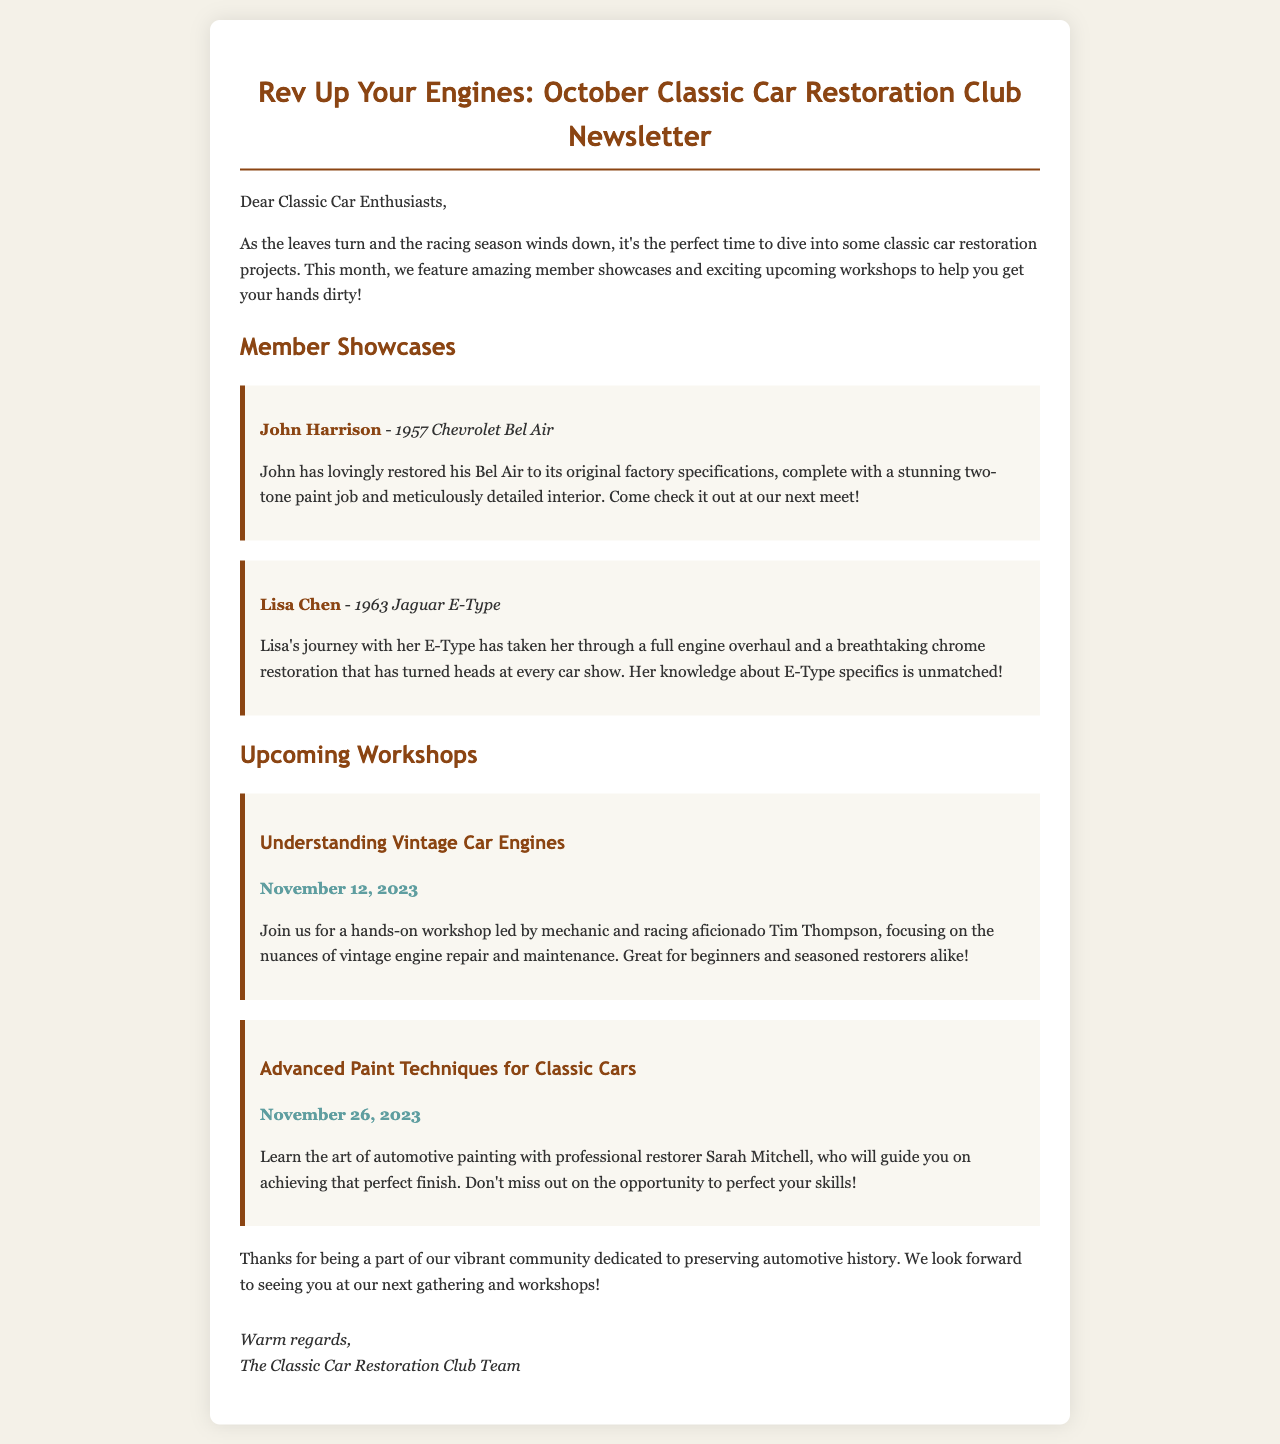What is the title of the newsletter? The title is displayed prominently at the top of the document.
Answer: Rev Up Your Engines: October Classic Car Restoration Club Newsletter Who restored the 1957 Chevrolet Bel Air? The member showcase section identifies the owner of the car.
Answer: John Harrison What is the date of the workshop on vintage car engines? The date is mentioned clearly under the workshop section related to vintage car engines.
Answer: November 12, 2023 Which car model did Lisa Chen restore? The member showcase provides the details of the car associated with Lisa Chen.
Answer: 1963 Jaguar E-Type Who is leading the workshop on painting techniques? This information is specified in the details of the workshop on advanced painting techniques.
Answer: Sarah Mitchell What color is the paint job on John Harrison's Bel Air? The description includes specific details about the paint job on the car.
Answer: Two-tone What is the focus of the workshop on November 12, 2023? The workshop's subject is outlined in the description of the event.
Answer: Vintage engine repair and maintenance How many member showcases are mentioned in the newsletter? The number of showcases is evident based on the structure of the member showcase section.
Answer: Two 